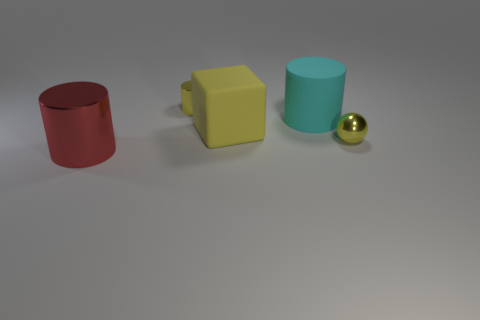Subtract all large matte cylinders. How many cylinders are left? 2 Add 1 large yellow objects. How many objects exist? 6 Subtract all yellow cylinders. How many cylinders are left? 2 Subtract 3 cylinders. How many cylinders are left? 0 Subtract all brown balls. Subtract all gray cubes. How many balls are left? 1 Subtract all green blocks. How many cyan cylinders are left? 1 Subtract all small objects. Subtract all purple metallic spheres. How many objects are left? 3 Add 4 big red things. How many big red things are left? 5 Add 1 cyan rubber cylinders. How many cyan rubber cylinders exist? 2 Subtract 1 yellow balls. How many objects are left? 4 